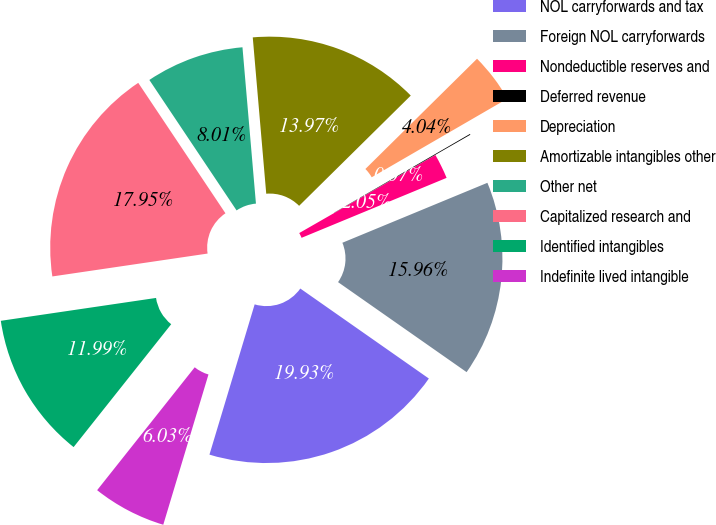Convert chart. <chart><loc_0><loc_0><loc_500><loc_500><pie_chart><fcel>NOL carryforwards and tax<fcel>Foreign NOL carryforwards<fcel>Nondeductible reserves and<fcel>Deferred revenue<fcel>Depreciation<fcel>Amortizable intangibles other<fcel>Other net<fcel>Capitalized research and<fcel>Identified intangibles<fcel>Indefinite lived intangible<nl><fcel>19.93%<fcel>15.96%<fcel>2.05%<fcel>0.07%<fcel>4.04%<fcel>13.97%<fcel>8.01%<fcel>17.95%<fcel>11.99%<fcel>6.03%<nl></chart> 